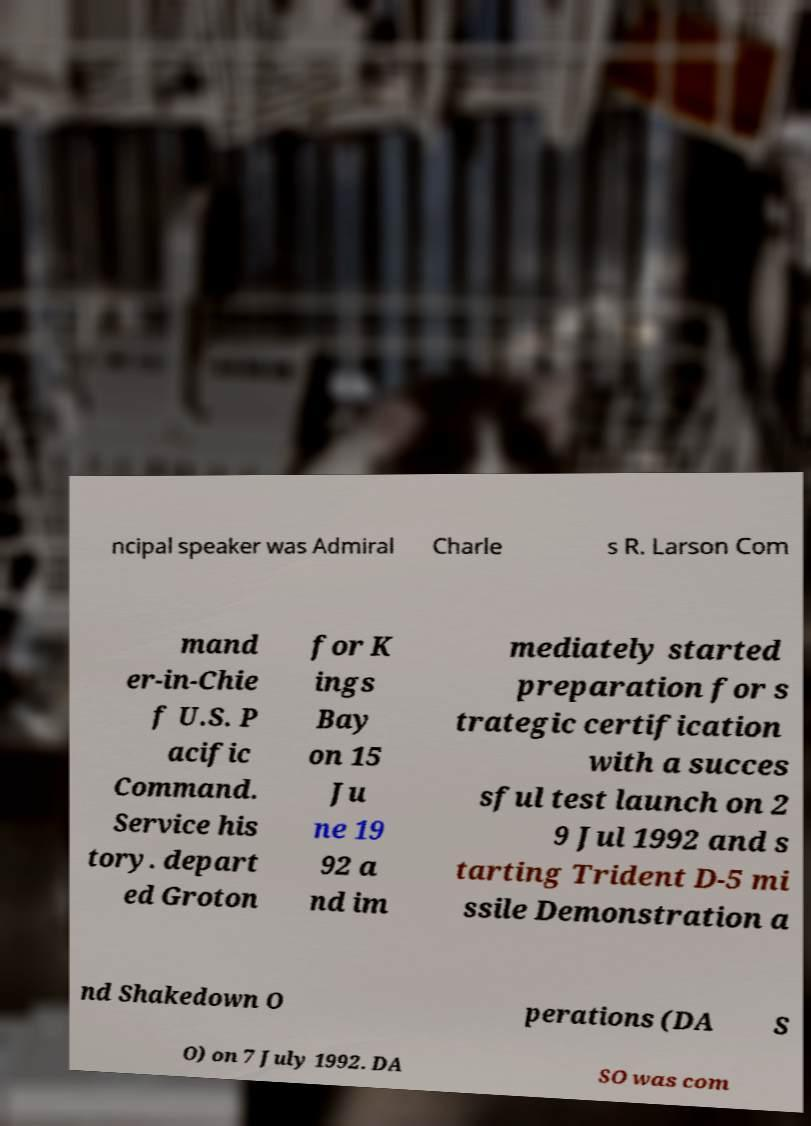Please identify and transcribe the text found in this image. ncipal speaker was Admiral Charle s R. Larson Com mand er-in-Chie f U.S. P acific Command. Service his tory. depart ed Groton for K ings Bay on 15 Ju ne 19 92 a nd im mediately started preparation for s trategic certification with a succes sful test launch on 2 9 Jul 1992 and s tarting Trident D-5 mi ssile Demonstration a nd Shakedown O perations (DA S O) on 7 July 1992. DA SO was com 